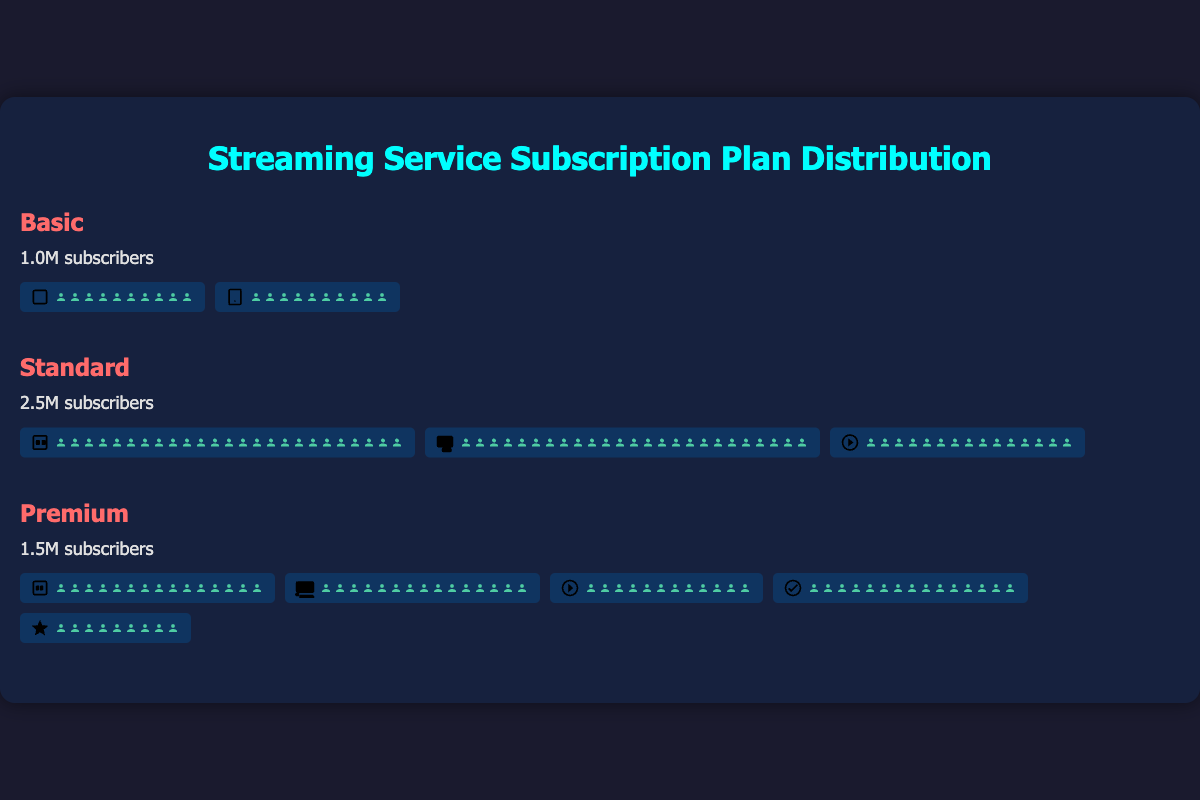What is the total number of subscribers for all plans combined? The combined total of subscribers is the sum of subscribers for Basic, Standard, and Premium plans: 1,000,000 (Basic) + 2,500,000 (Standard) + 1,500,000 (Premium) = 5,000,000.
Answer: 5,000,000 Which subscription plan has the largest number of subscribers? By looking at the subscribers for each plan, the Standard plan has the largest number with 2,500,000 subscribers.
Answer: Standard How many features are utilized in total across all plans? Features used in Basic: 2, Standard: 3, Premium: 5. Adding these, 2 + 3 + 5 = 10 features used in total across all plans.
Answer: 10 How does the subscriber count of the Premium plan compare to the Basic plan? The Premium plan has 1,500,000 subscribers whereas the Basic plan has 1,000,000. Premium has 500,000 more.
Answer: Premium has 500,000 more What are the shared features between the Standard and Premium plans? Both Standard and Premium plans include the offline viewing feature. No other features overlap.
Answer: offline viewing What's the ratio of Ultra High Definition users to High Definition users? Ultra High Definition users (1,500,000) to High Definition users (2,500,000) ratio is 1,500,000 / 2,500,000 = 0.6.
Answer: 0.6 What percentage of Premium subscribers utilize the Ad-Free feature? All Premium subscribers (1,500,000) utilize the Ad-Free feature. Percentage = (1,500,000 / 1,500,000) * 100 = 100%.
Answer: 100% What is the average number of subscribers per plan? Total subscribers: 5,000,000 across 3 plans. Average = 5,000,000 / 3 ≈ 1,666,667 subscribers per plan.
Answer: ~1,666,667 Among subscribers who use offline viewing, what percentage are Standard plan users? Offline viewing users in Standard: 1,500,000, and in Premium: 1,200,000. Total offline viewing users = 1,500,000 + 1,200,000 = 2,700,000. Percentage = (1,500,000 / 2,700,000) * 100 ≈ 55.56%.
Answer: ~55.56% Which plan has the highest number of features utilized by subscribers? Premium plan has the highest with 5 features used.
Answer: Premium 